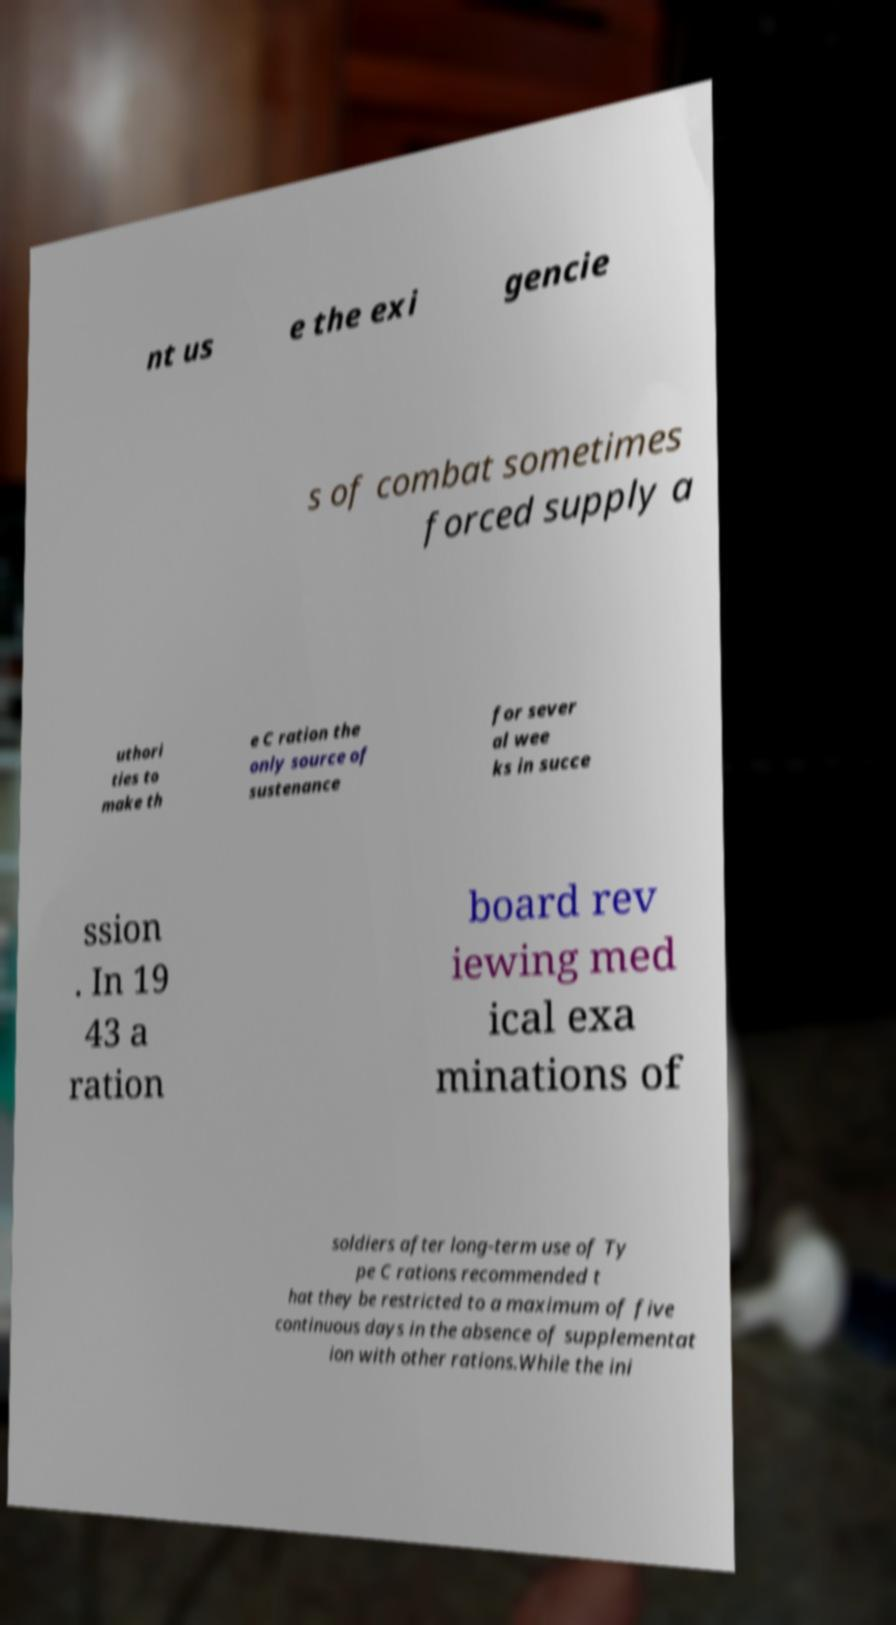Could you assist in decoding the text presented in this image and type it out clearly? nt us e the exi gencie s of combat sometimes forced supply a uthori ties to make th e C ration the only source of sustenance for sever al wee ks in succe ssion . In 19 43 a ration board rev iewing med ical exa minations of soldiers after long-term use of Ty pe C rations recommended t hat they be restricted to a maximum of five continuous days in the absence of supplementat ion with other rations.While the ini 